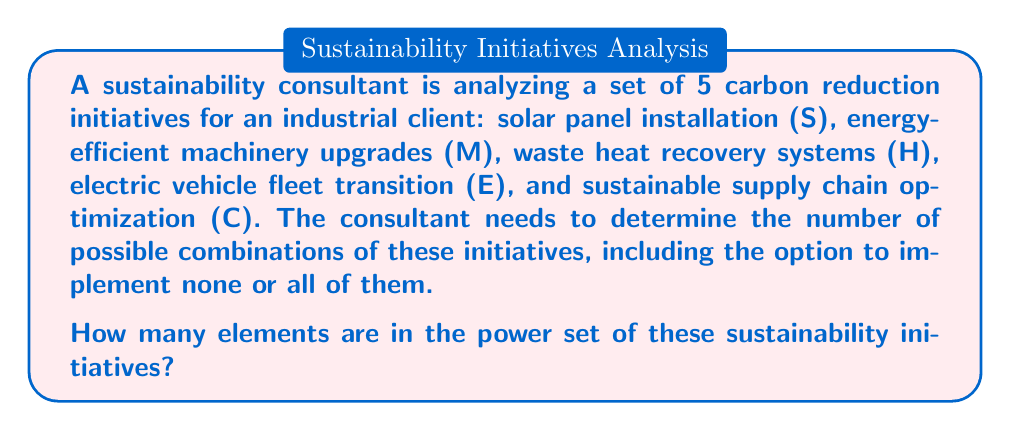Can you answer this question? To solve this problem, we need to understand the concept of a power set and apply it to the given set of sustainability initiatives.

1. Power Set Definition:
   The power set of a set S is the set of all subsets of S, including the empty set and S itself.

2. Given Information:
   We have a set of 5 sustainability initiatives: {S, M, H, E, C}

3. Power Set Calculation:
   For a set with n elements, the number of elements in its power set is given by the formula:
   
   $$|\mathcal{P}(S)| = 2^n$$
   
   Where:
   - $|\mathcal{P}(S)|$ is the cardinality (number of elements) of the power set
   - $n$ is the number of elements in the original set

4. Applying the Formula:
   In this case, $n = 5$ (the number of sustainability initiatives)
   
   $$|\mathcal{P}(S)| = 2^5 = 32$$

5. Interpretation:
   This means there are 32 possible combinations of sustainability initiatives, including:
   - The empty set (implementing no initiatives)
   - 5 sets with one initiative each
   - 10 sets with two initiatives each
   - 10 sets with three initiatives each
   - 5 sets with four initiatives each
   - The full set (implementing all five initiatives)

   We can verify this: $1 + 5 + 10 + 10 + 5 + 1 = 32$

Therefore, the power set of the sustainability initiatives contains 32 elements, representing all possible combinations of these carbon reduction strategies.
Answer: The power set of the 5 sustainability initiatives contains 32 elements. 